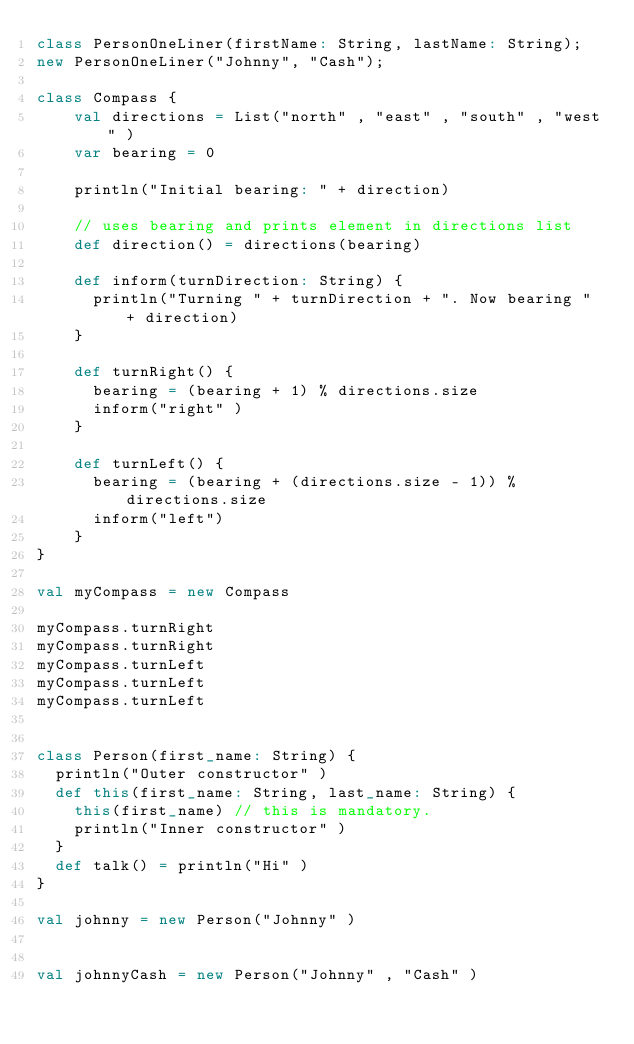Convert code to text. <code><loc_0><loc_0><loc_500><loc_500><_Scala_>class PersonOneLiner(firstName: String, lastName: String);
new PersonOneLiner("Johnny", "Cash");

class Compass {
    val directions = List("north" , "east" , "south" , "west" )
    var bearing = 0

    println("Initial bearing: " + direction)

    // uses bearing and prints element in directions list
    def direction() = directions(bearing)

    def inform(turnDirection: String) {
      println("Turning " + turnDirection + ". Now bearing " + direction)
    }

    def turnRight() {
      bearing = (bearing + 1) % directions.size
      inform("right" )
    }

    def turnLeft() {
      bearing = (bearing + (directions.size - 1)) % directions.size
      inform("left")
    }
}

val myCompass = new Compass

myCompass.turnRight
myCompass.turnRight
myCompass.turnLeft
myCompass.turnLeft
myCompass.turnLeft


class Person(first_name: String) {
  println("Outer constructor" )
  def this(first_name: String, last_name: String) {
    this(first_name) // this is mandatory.
    println("Inner constructor" )
  }
  def talk() = println("Hi" )
}

val johnny = new Person("Johnny" )


val johnnyCash = new Person("Johnny" , "Cash" )

</code> 